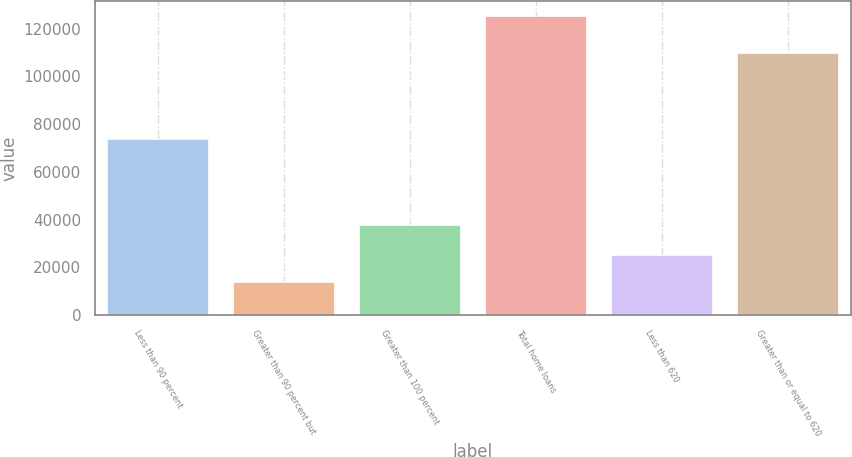<chart> <loc_0><loc_0><loc_500><loc_500><bar_chart><fcel>Less than 90 percent<fcel>Greater than 90 percent but<fcel>Greater than 100 percent<fcel>Total home loans<fcel>Less than 620<fcel>Greater than or equal to 620<nl><fcel>73680<fcel>14038<fcel>37673<fcel>125391<fcel>25173.3<fcel>109897<nl></chart> 